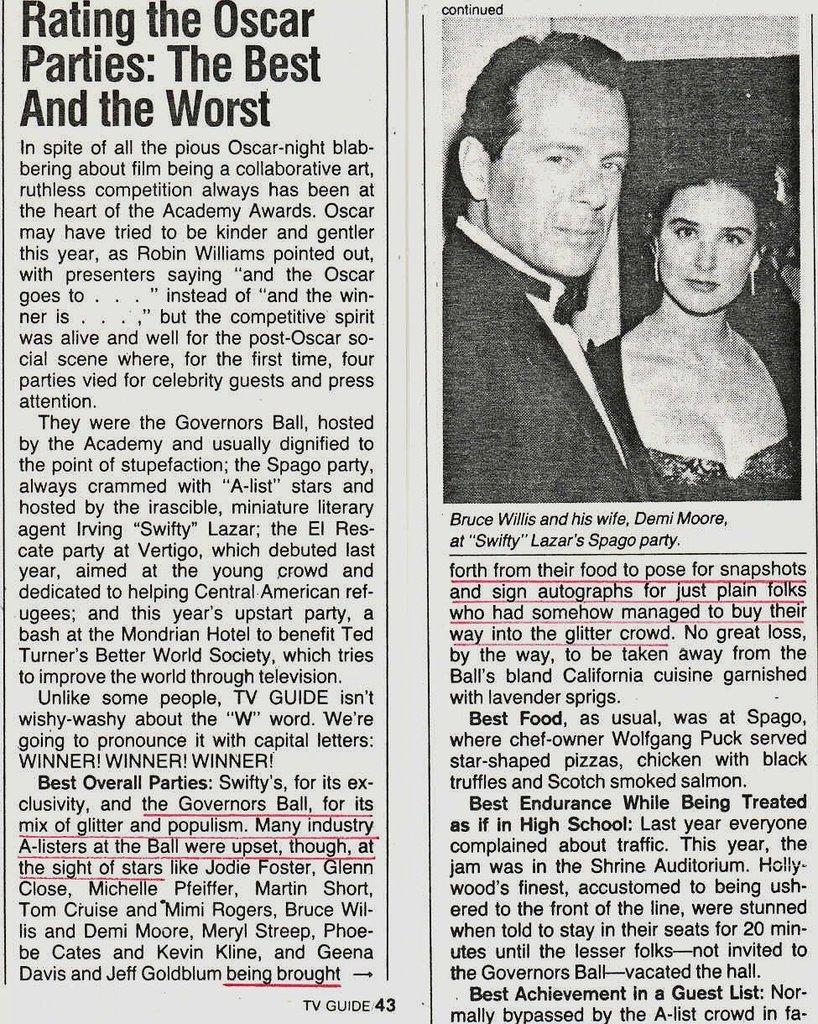Could you give a brief overview of what you see in this image? In this picture I can see a paper with some text and image of the people. 